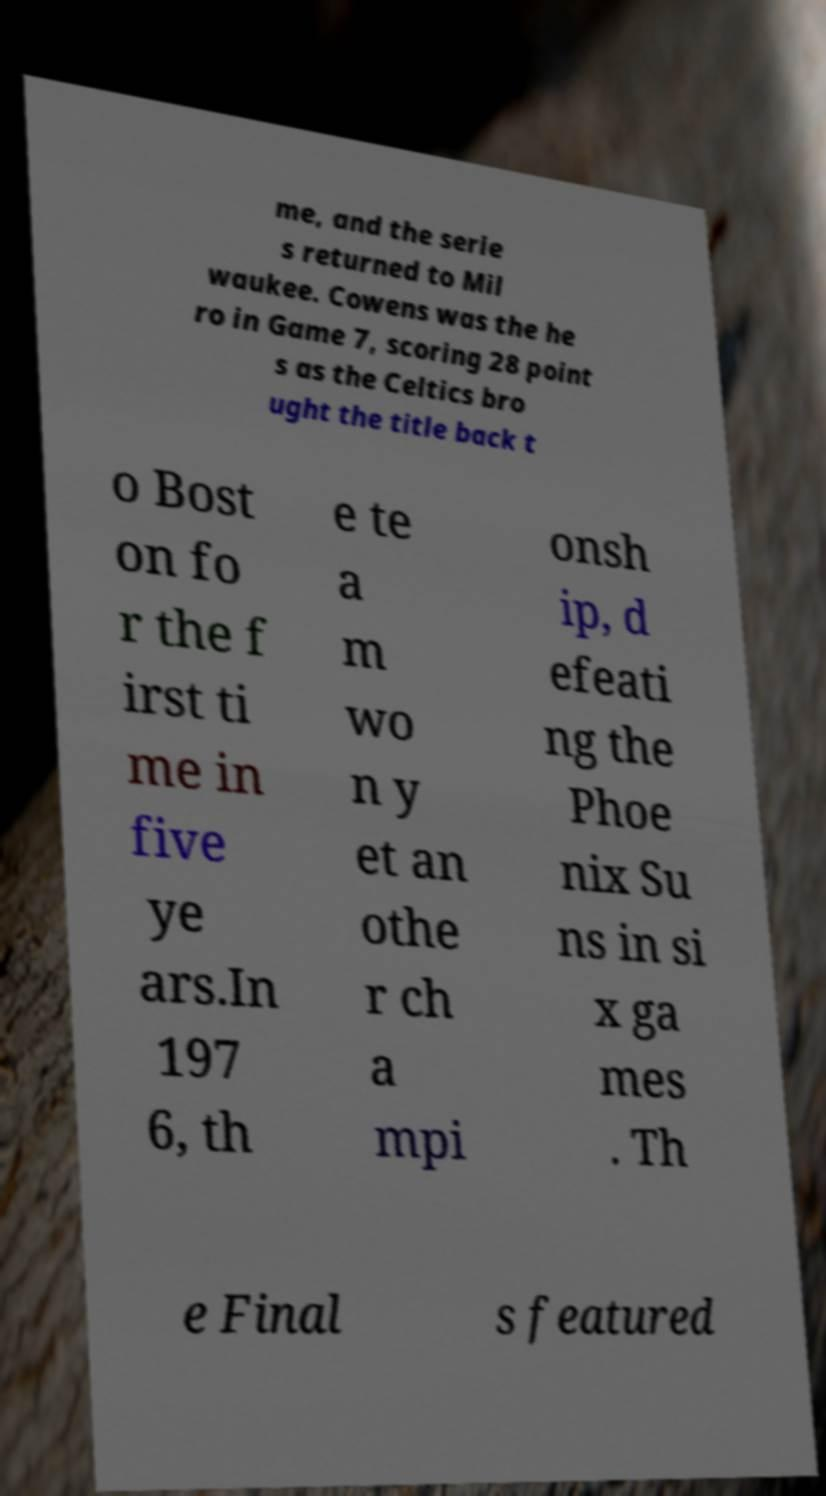Can you read and provide the text displayed in the image?This photo seems to have some interesting text. Can you extract and type it out for me? me, and the serie s returned to Mil waukee. Cowens was the he ro in Game 7, scoring 28 point s as the Celtics bro ught the title back t o Bost on fo r the f irst ti me in five ye ars.In 197 6, th e te a m wo n y et an othe r ch a mpi onsh ip, d efeati ng the Phoe nix Su ns in si x ga mes . Th e Final s featured 